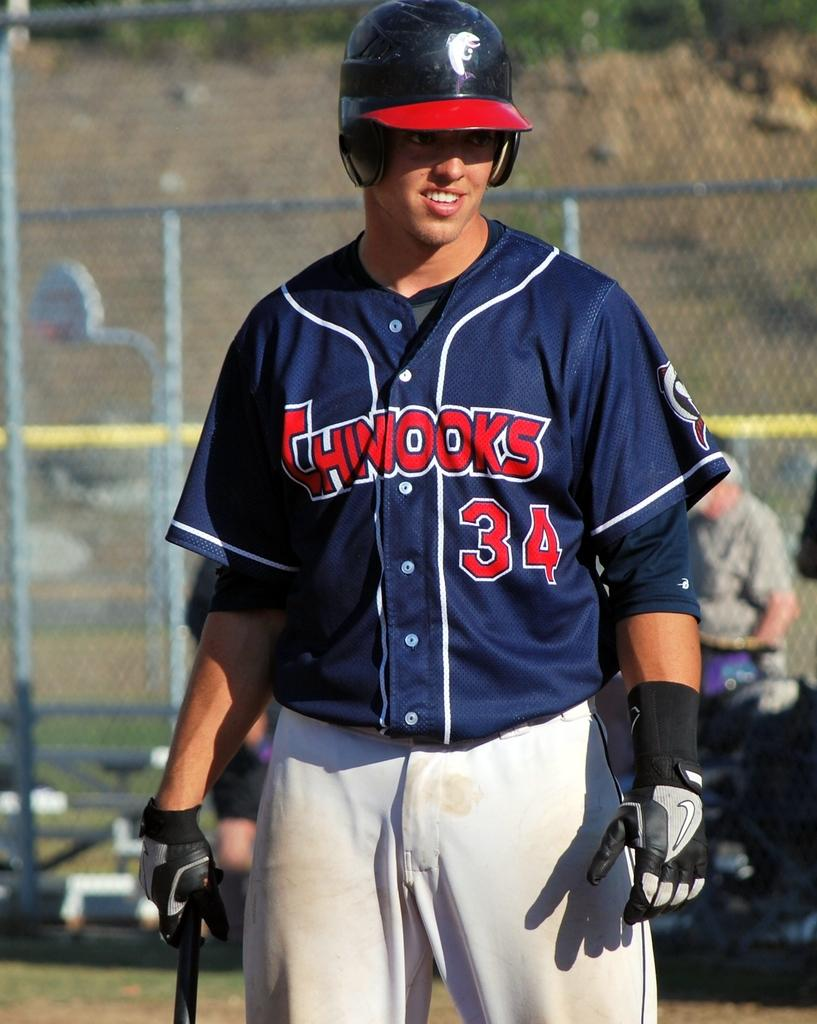<image>
Create a compact narrative representing the image presented. A man wearing a blue Chinooks jersey and batters cap. 